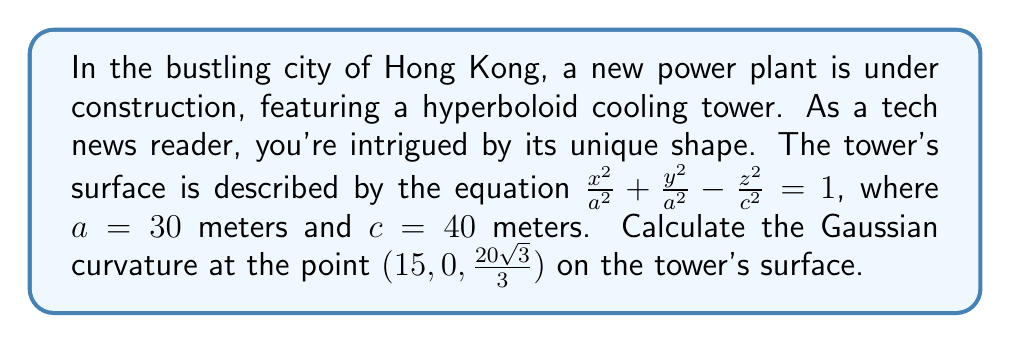Solve this math problem. To find the Gaussian curvature of the hyperboloid cooling tower, we'll follow these steps:

1) The hyperboloid of one sheet is given by the equation:
   $$\frac{x^2}{a^2} + \frac{y^2}{a^2} - \frac{z^2}{c^2} = 1$$

2) We can parameterize this surface using $u$ and $v$:
   $$x = a\cosh u \cos v$$
   $$y = a\cosh u \sin v$$
   $$z = c\sinh u$$

3) The first fundamental form coefficients are:
   $$E = a^2\sinh^2 u + a^2\cosh^2 u = a^2(\sinh^2 u + \cosh^2 u) = a^2\cosh(2u)$$
   $$F = 0$$
   $$G = a^2\cosh^2 u$$

4) The second fundamental form coefficients are:
   $$L = \frac{ac}{\sqrt{a^2\sinh^2 u + c^2\cosh^2 u}}$$
   $$M = 0$$
   $$N = \frac{ac\cosh^2 u}{\sqrt{a^2\sinh^2 u + c^2\cosh^2 u}}$$

5) The Gaussian curvature is given by:
   $$K = \frac{LN - M^2}{EG - F^2} = \frac{LN}{EG}$$

6) Substituting the values:
   $$K = \frac{ac \cdot ac\cosh^2 u}{(a^2\cosh(2u))(a^2\cosh^2 u)(a^2\sinh^2 u + c^2\cosh^2 u)} = -\frac{c^2}{a^2(a^2\sinh^2 u + c^2\cosh^2 u)^2}$$

7) For the point $(15, 0, \frac{20\sqrt{3}}{3})$:
   $$\cosh u = \frac{15}{30} = \frac{1}{2}$$
   $$\sinh u = \frac{\sqrt{3}}{2}$$

8) Substituting these values and $a=30$, $c=40$:
   $$K = -\frac{40^2}{30^2(30^2(\frac{\sqrt{3}}{2})^2 + 40^2(\frac{1}{2})^2)^2}$$

9) Simplifying:
   $$K = -\frac{1600}{900(675 + 400)^2} = -\frac{1600}{900(1075)^2} \approx -1.53 \times 10^{-6} \text{ m}^{-2}$$
Answer: $K \approx -1.53 \times 10^{-6} \text{ m}^{-2}$ 